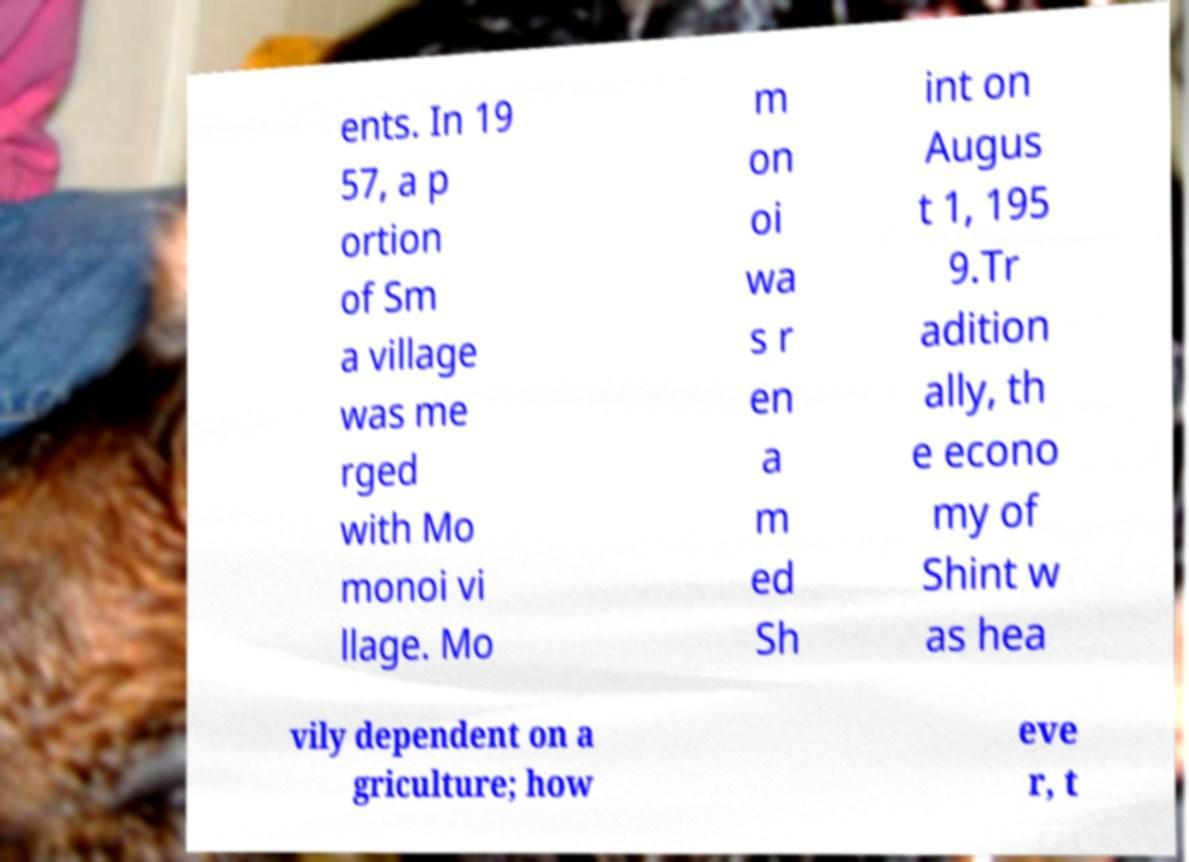Please identify and transcribe the text found in this image. ents. In 19 57, a p ortion of Sm a village was me rged with Mo monoi vi llage. Mo m on oi wa s r en a m ed Sh int on Augus t 1, 195 9.Tr adition ally, th e econo my of Shint w as hea vily dependent on a griculture; how eve r, t 